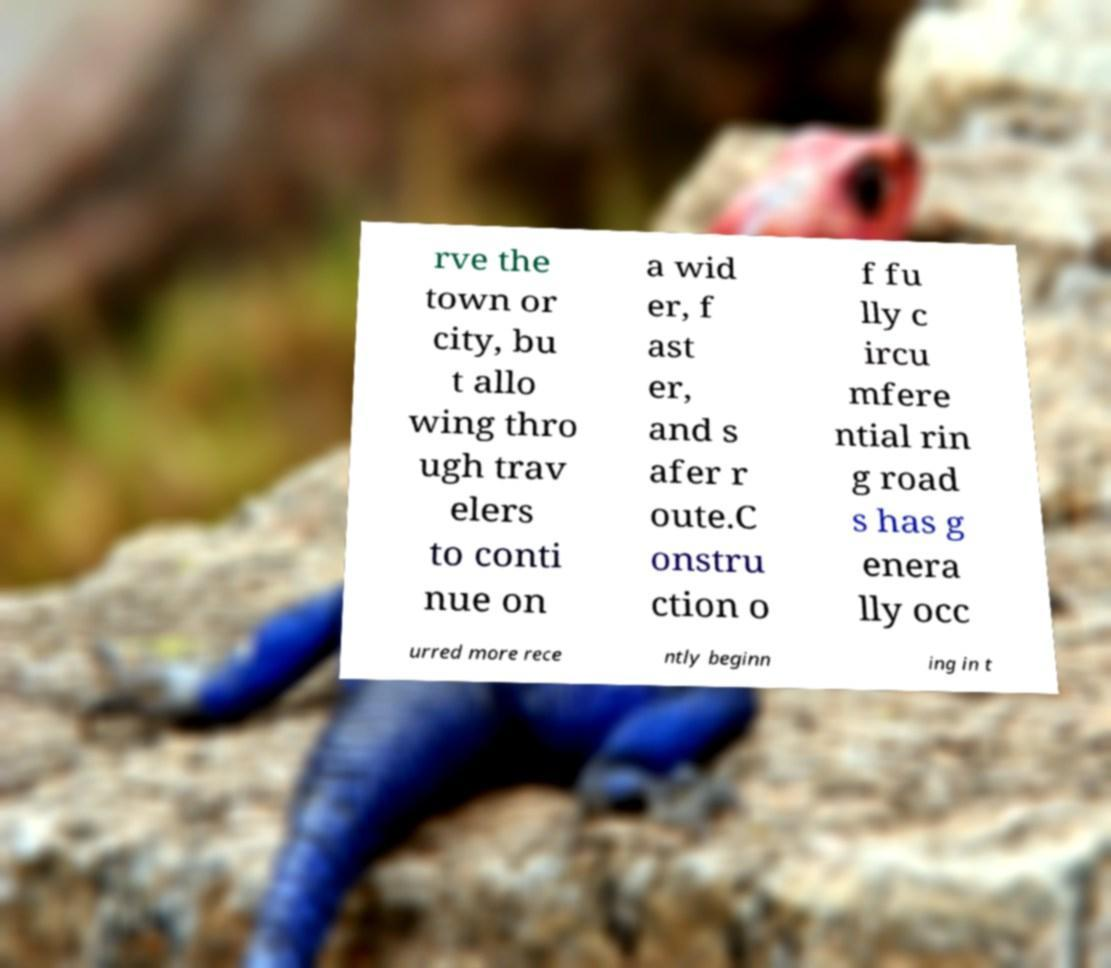Please read and relay the text visible in this image. What does it say? rve the town or city, bu t allo wing thro ugh trav elers to conti nue on a wid er, f ast er, and s afer r oute.C onstru ction o f fu lly c ircu mfere ntial rin g road s has g enera lly occ urred more rece ntly beginn ing in t 